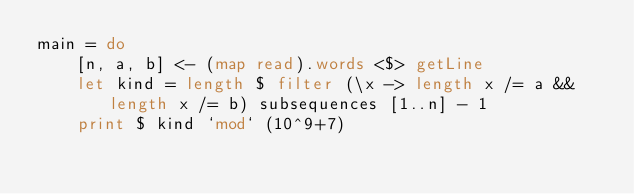Convert code to text. <code><loc_0><loc_0><loc_500><loc_500><_Haskell_>main = do
    [n, a, b] <- (map read).words <$> getLine
    let kind = length $ filter (\x -> length x /= a && length x /= b) subsequences [1..n] - 1
    print $ kind `mod` (10^9+7)</code> 